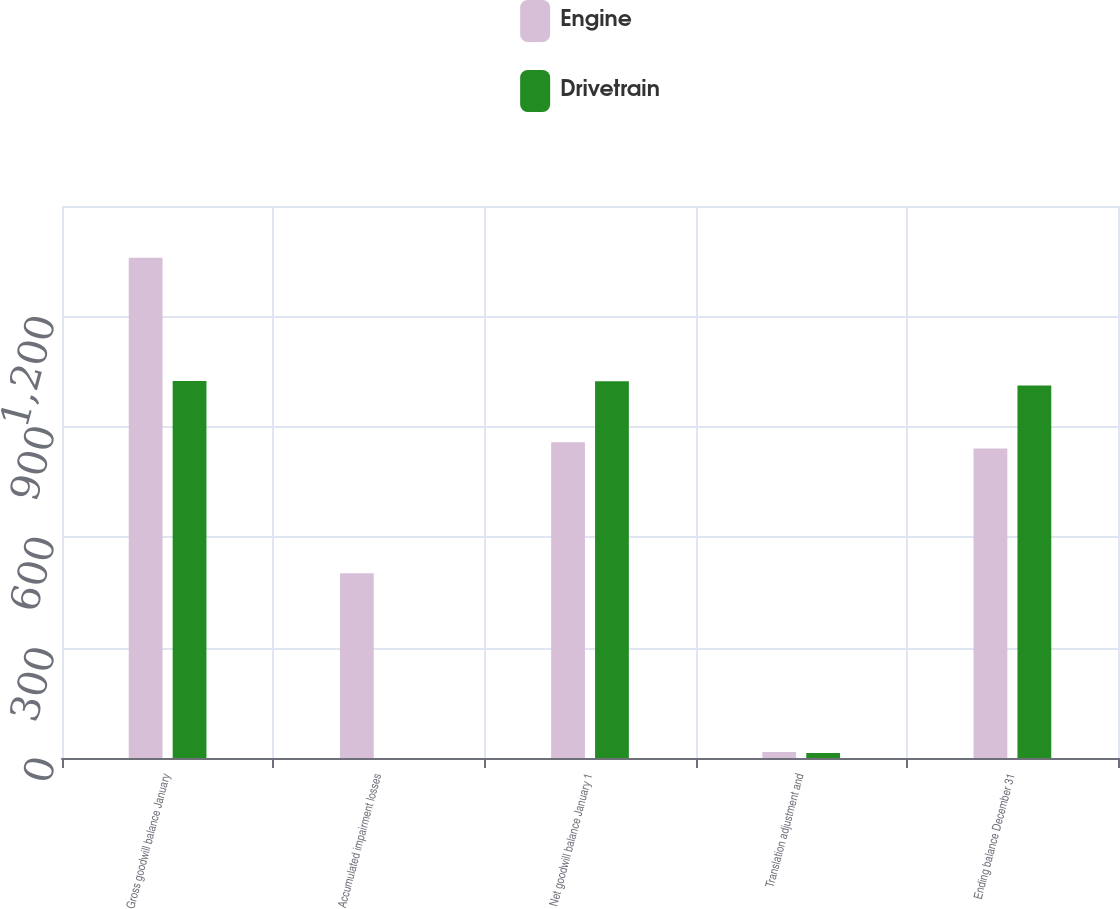<chart> <loc_0><loc_0><loc_500><loc_500><stacked_bar_chart><ecel><fcel>Gross goodwill balance January<fcel>Accumulated impairment losses<fcel>Net goodwill balance January 1<fcel>Translation adjustment and<fcel>Ending balance December 31<nl><fcel>Engine<fcel>1359.6<fcel>501.8<fcel>857.8<fcel>16.5<fcel>841.3<nl><fcel>Drivetrain<fcel>1024.2<fcel>0.2<fcel>1024<fcel>13.6<fcel>1012.1<nl></chart> 